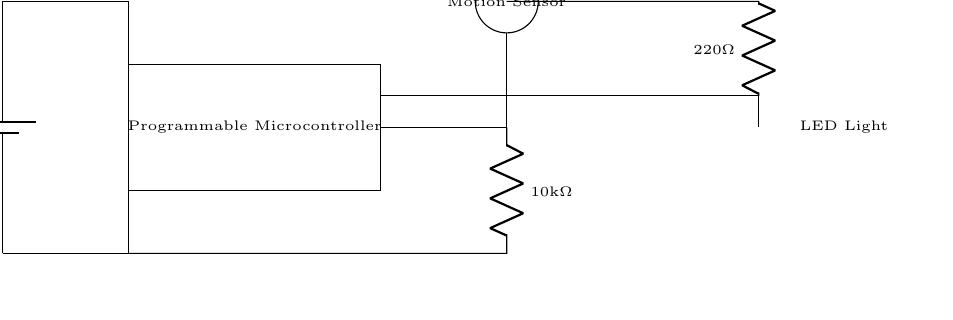What is the voltage of the power supply? The power supply in this circuit diagram is labeled as twelve volts, which indicates the potential difference supplied to the circuit.
Answer: twelve volts What type of sensor is used in this circuit? The diagram features a motion sensor, indicated by a circular shape and labeled accordingly. This details its use as a sensing component within the lighting system.
Answer: motion sensor What is the function of the programmable microcontroller? The programmable microcontroller is responsible for processing inputs from the motion sensor and controlling the LED light. It orchestrates the automation aspect of the lighting system.
Answer: control How many resistors are present in the circuit? There are two resistors shown in the circuit diagram, one for the motion sensor and another for the LED light. This can be confirmed by counting the labeled resistor elements in the layout.
Answer: two What is the resistance value of the resistor connected to the motion sensor? The resistance value associated with the resistor connected to the motion sensor is labeled as ten kilo ohms, indicating its resistance in the circuit.
Answer: ten kilo ohms If the motion sensor detects movement, what component is activated? When the motion sensor detects movement, it sends a signal to the programmable microcontroller, which in turn activates the LED light as part of the automated system.
Answer: LED light What is the purpose of the LED light in this circuit? The LED light serves as the output that provides illumination when the motion sensor is triggered, representing the primary function of the automated smart home lighting system.
Answer: illumination 